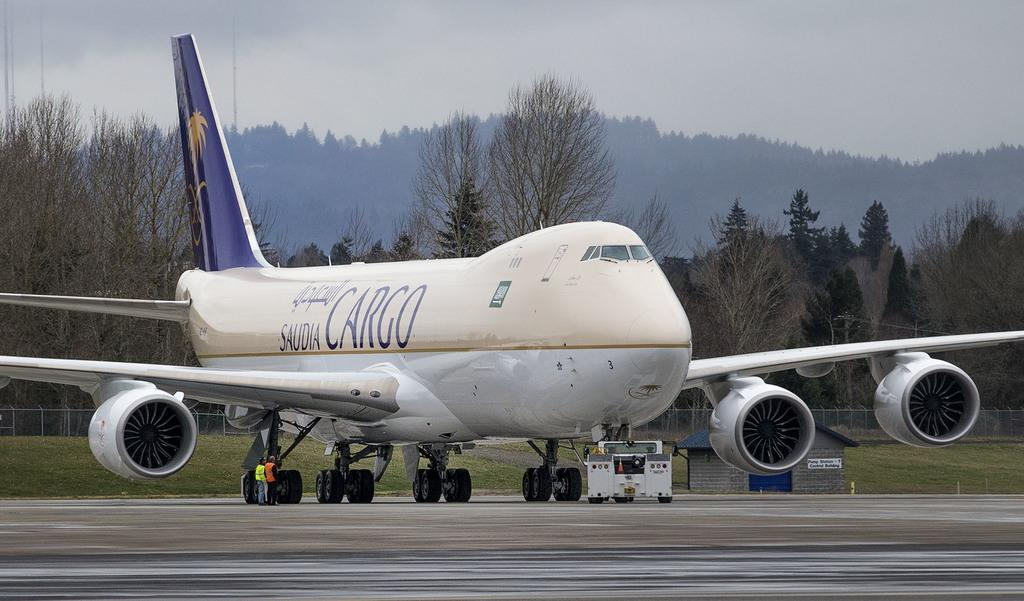<image>
Provide a brief description of the given image. A plan on the runway reads "CARGO" on the side. 